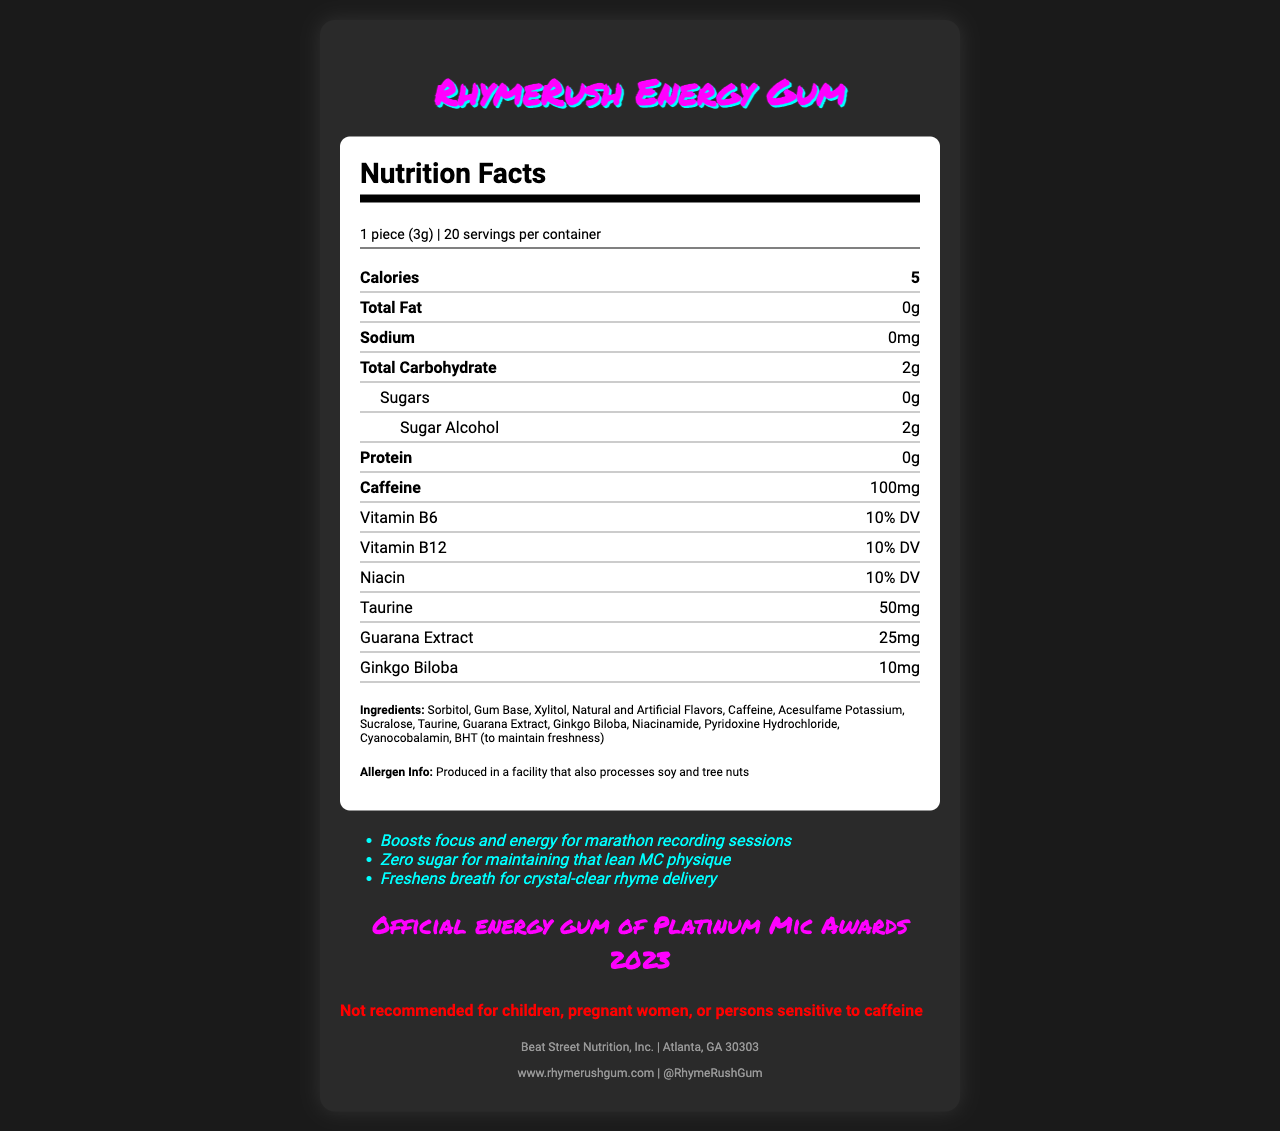What is the serving size for RhymeRush Energy Gum? The serving size is specified at the top of the nutrition label as "1 piece (3g)".
Answer: 1 piece (3g) How many calories are in one serving of RhymeRush Energy Gum? The calories per serving is listed right under the serving information as "Calories: 5".
Answer: 5 calories What are the total carbohydrates per serving? The total carbohydrates per serving is listed as "2 grams" in the nutrient rows.
Answer: 2 grams How much caffeine does one piece of RhymeRush Energy Gum contain? The amount of caffeine is explicitly stated in the nutrient row as "Caffeine: 100mg".
Answer: 100 milligrams List one marketing claim made by the product. One of the marketing claims listed is "Boosts focus and energy for marathon recording sessions".
Answer: Boosts focus and energy for marathon recording sessions Does this gum contain any sugar? The label states that there are "0 grams" of sugars in each serving.
Answer: No What percentage of the Daily Value for Vitamin B6 does one piece provide? The nutrition label indicates that one piece provides "10% DV" of Vitamin B6.
Answer: 10% DV Which organization endorses this energy gum? The endorsement section mentions "Official energy gum of Platinum Mic Awards 2023".
Answer: Platinum Mic Awards 2023 What is the main allergen concern for this product? The allergen information states that it is processed in a facility that also processes "soy and tree nuts".
Answer: Soy and tree nuts Where is the manufacturer of RhymeRush Energy Gum located? The manufacturer address is listed as "Atlanta, GA 30303".
Answer: Atlanta, GA 30303 What is the recommended use warning for this product? The warning section details that it is "Not recommended for children, pregnant women, or persons sensitive to caffeine".
Answer: Not recommended for children, pregnant women, or persons sensitive to caffeine What type of sweeteners does this gum contain? A. Sugar and High Fructose Corn Syrup B. Sorbitol, Xylitol, Acesulfame Potassium, Sucralose C. Aspartame and Saccharin The ingredients list includes "Sorbitol, Xylitol, Acesulfame Potassium, Sucralose".
Answer: B Which vitamin is not listed in the nutrition facts? A. Vitamin B6 B. Vitamin B12 C. Vitamin C D. Niacin Vitamin C is not listed in the nutrition facts, while Vitamin B6, B12, and Niacin are all included.
Answer: C Does this gum contain protein? The protein content is listed as "0 grams" in the nutrient rows.
Answer: No Please summarize the main features of RhymeRush Energy Gum. This summary captures the key attributes such as serving size, calorie content, special ingredients, target audience, endorsements, and manufacturer details.
Answer: RhymeRush Energy Gum is a low-calorie, high-caffeine chewing gum designed to boost focus and energy, especially popular among rappers. Each piece contains 5 calories, 2 grams of carbohydrates, and 100 milligrams of caffeine, along with vitamins B6, B12, niacin, taurine, guarana extract, and ginkgo biloba. The gum is sugar-free, with sweeteners like sorbitol and xylitol. It is not recommended for children, pregnant women, or those sensitive to caffeine. This gum is endorsed by the Platinum Mic Awards and made by Beat Street Nutrition in Atlanta, GA. Why does the chewing gum contain ginkgo biloba? The document does not provide information on why ginkgo biloba is included in the ingredients.
Answer: Cannot be determined 